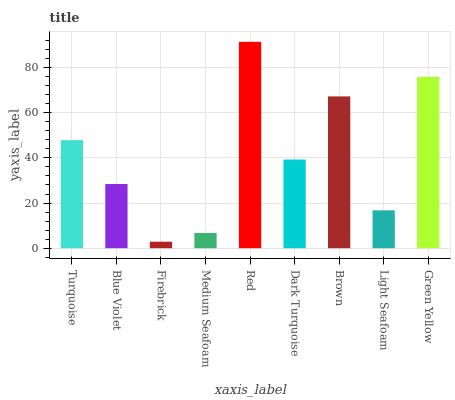Is Firebrick the minimum?
Answer yes or no. Yes. Is Red the maximum?
Answer yes or no. Yes. Is Blue Violet the minimum?
Answer yes or no. No. Is Blue Violet the maximum?
Answer yes or no. No. Is Turquoise greater than Blue Violet?
Answer yes or no. Yes. Is Blue Violet less than Turquoise?
Answer yes or no. Yes. Is Blue Violet greater than Turquoise?
Answer yes or no. No. Is Turquoise less than Blue Violet?
Answer yes or no. No. Is Dark Turquoise the high median?
Answer yes or no. Yes. Is Dark Turquoise the low median?
Answer yes or no. Yes. Is Medium Seafoam the high median?
Answer yes or no. No. Is Green Yellow the low median?
Answer yes or no. No. 